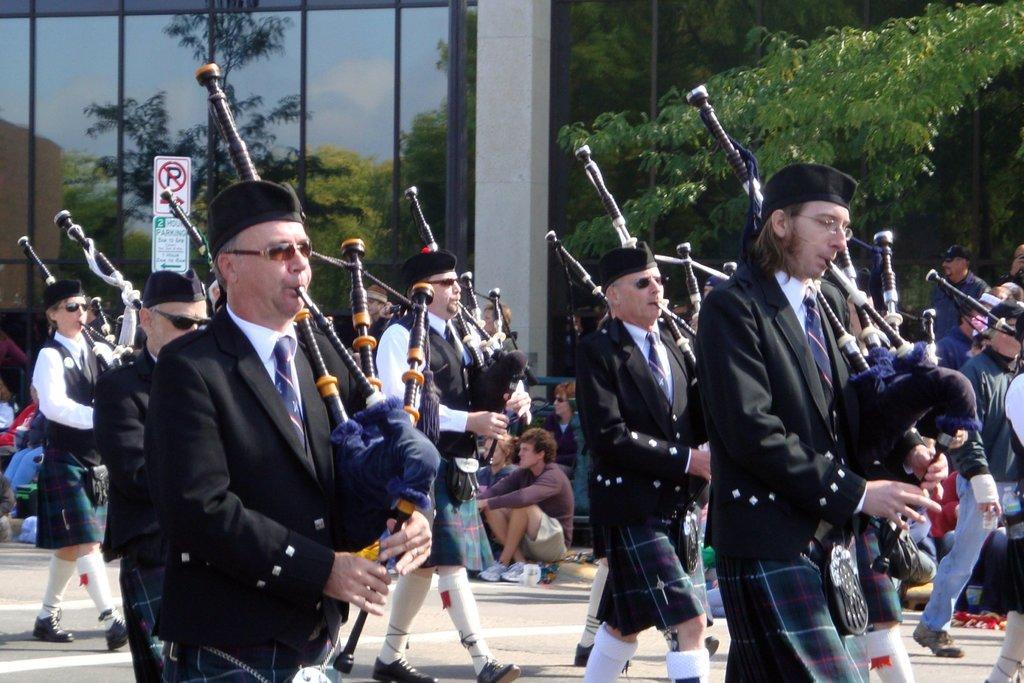Could you give a brief overview of what you see in this image? There are people in the foreground area of the image, by holding musical instruments in their hands, there are trees, building and a pole in the background. 